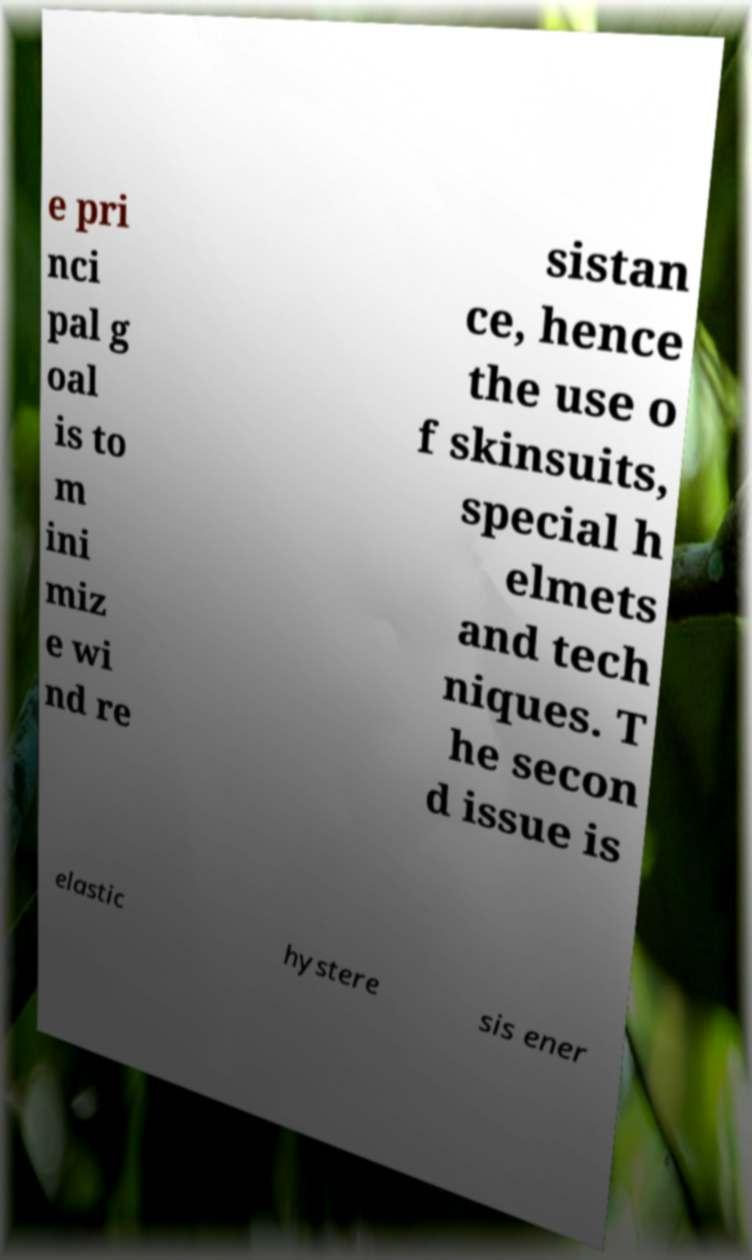Could you extract and type out the text from this image? e pri nci pal g oal is to m ini miz e wi nd re sistan ce, hence the use o f skinsuits, special h elmets and tech niques. T he secon d issue is elastic hystere sis ener 